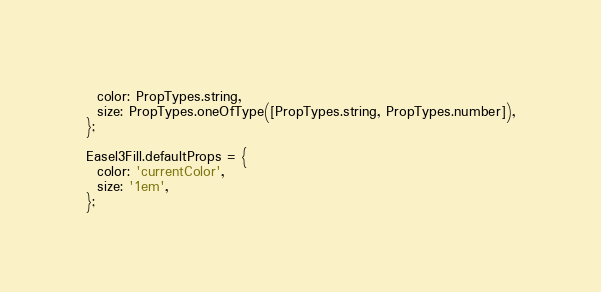<code> <loc_0><loc_0><loc_500><loc_500><_JavaScript_>  color: PropTypes.string,
  size: PropTypes.oneOfType([PropTypes.string, PropTypes.number]),
};

Easel3Fill.defaultProps = {
  color: 'currentColor',
  size: '1em',
};
</code> 